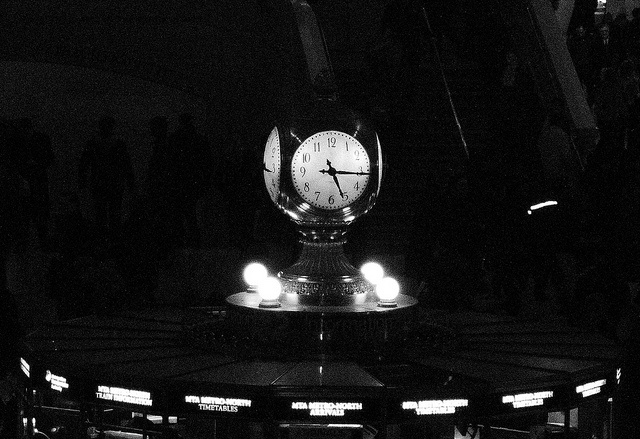Describe the objects in this image and their specific colors. I can see clock in black, lightgray, darkgray, and gray tones, clock in black, darkgray, lightgray, and gray tones, and clock in black, lightgray, darkgray, and gray tones in this image. 